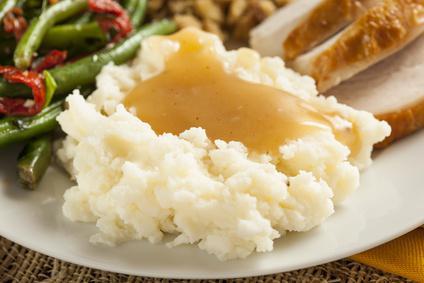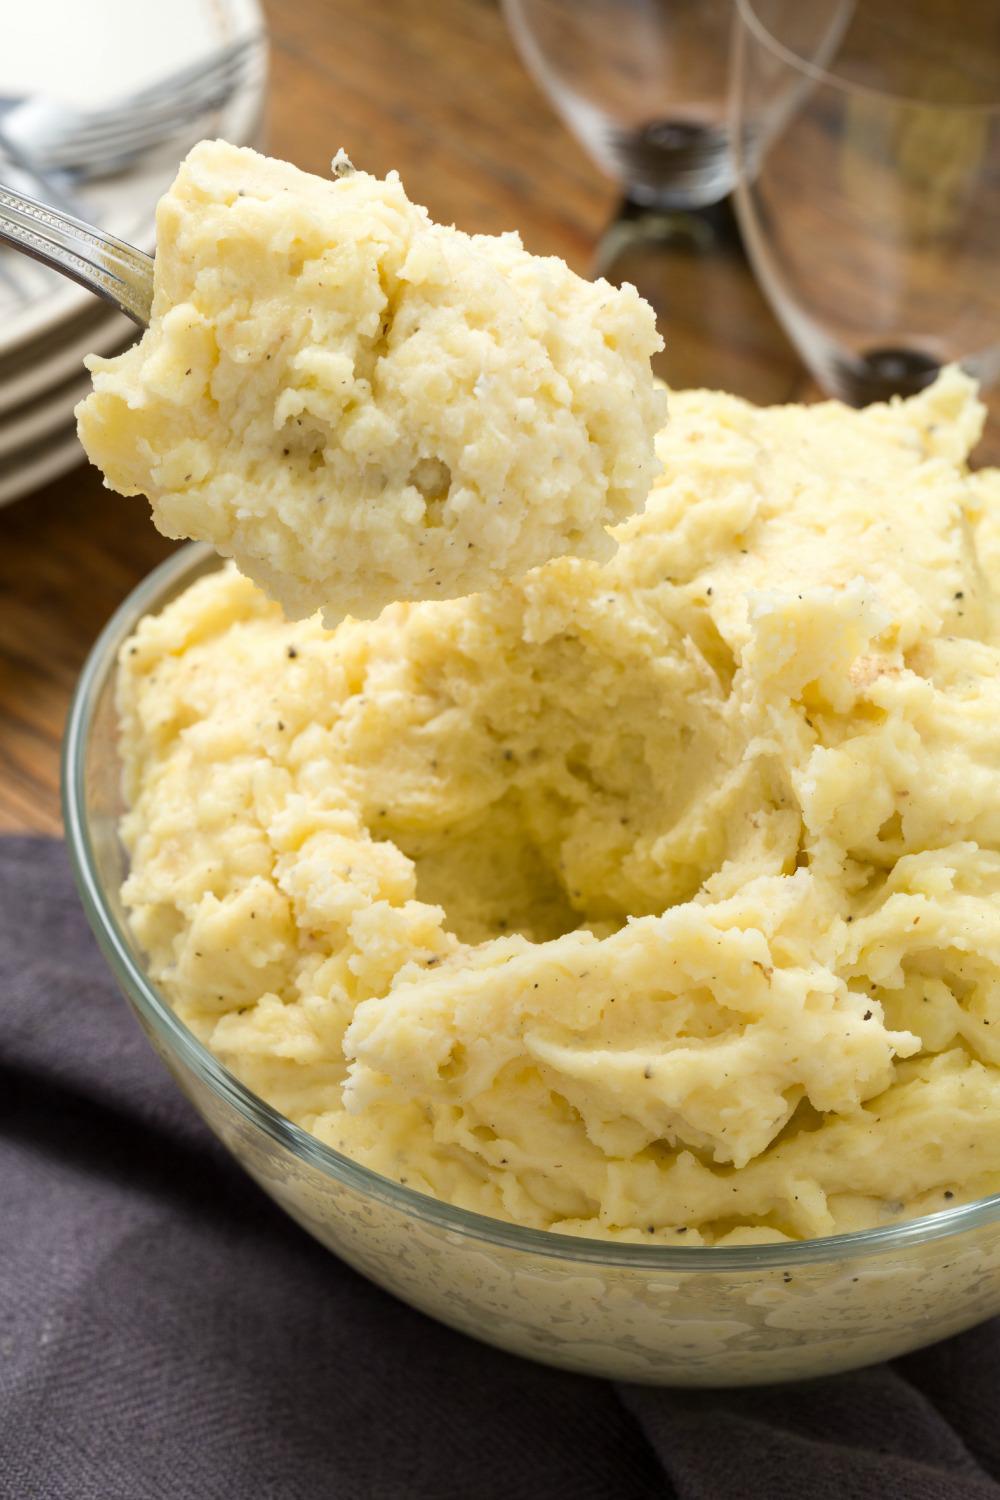The first image is the image on the left, the second image is the image on the right. Analyze the images presented: Is the assertion "there is a utensil in one of the images" valid? Answer yes or no. Yes. The first image is the image on the left, the second image is the image on the right. Analyze the images presented: Is the assertion "One bowl of potatoes has only green chive garnish." valid? Answer yes or no. No. 